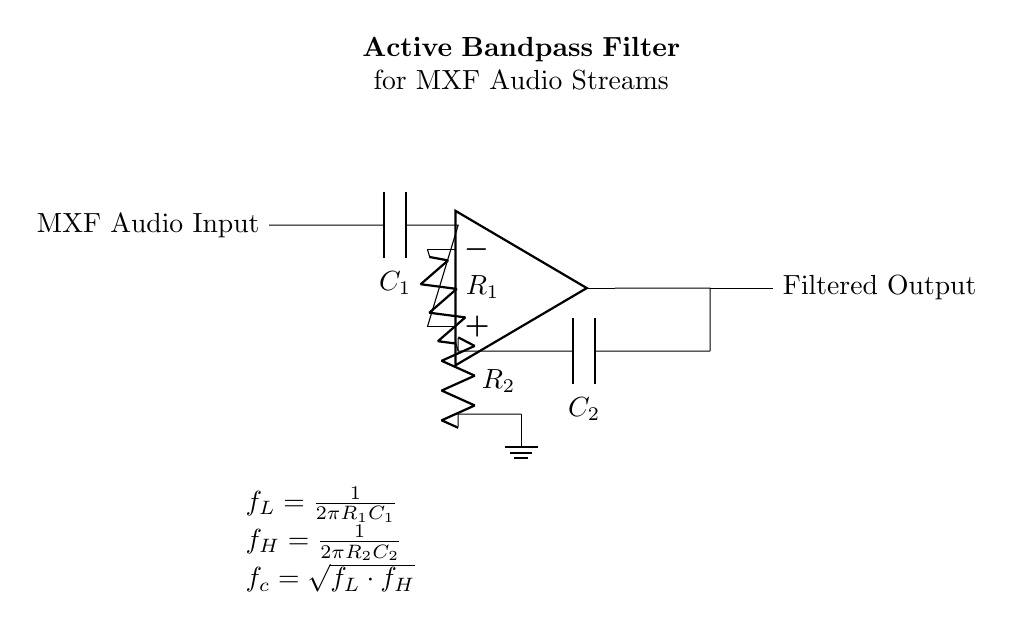What is the purpose of the capacitors in this filter? The capacitors \( C_1 \) and \( C_2 \) form frequency-selective components that allow certain frequency ranges to pass while blocking others. \( C_1 \) is connected to the input and helps define the lower cutoff frequency, while \( C_2 \) in the feedback network influences the upper cutoff frequency.
Answer: Frequency-selective components What do \( R_1 \) and \( R_2 \) control in the circuit? \( R_1 \) and \( R_2 \) are resistors that work in conjunction with capacitors \( C_1 \) and \( C_2 \) to set the cutoff frequencies of the bandpass filter. \( R_1 \) affects the lower cutoff frequency, and \( R_2 \) determines the upper cutoff frequency.
Answer: Cutoff frequencies What is the formula for the lower cutoff frequency? The formula for the lower cutoff frequency \( f_L \) is given as \( f_L = \frac{1}{2\pi R_1 C_1} \). This equation indicates how \( R_1 \) and \( C_1 \) interact to determine the frequency below which signals are attenuated.
Answer: \( \frac{1}{2\pi R_1 C_1} \) Which component connects the op-amp's output to ground? The resistor \( R_2 \) connects the op-amp's output to ground, forming part of the feedback loop that influences the circuit's gain and stability. It provides a feedback path for the op-amp, ensuring proper signal processing.
Answer: Resistor R2 How is the filtered output obtained in the circuit? The filtered output is obtained at the op-amp's output, where the processed audio signal is available after filtering has occurred. The op-amp amplifies the filtered signal based on the configuration of components.
Answer: Op-amp output What is the role of the op-amp in this circuit? The op-amp acts as an amplifier that enhances the signal after filtering has been applied. It allows for greater control over the gain and ensures that the desired frequency range is effectively amplified and outputted.
Answer: Amplifier 